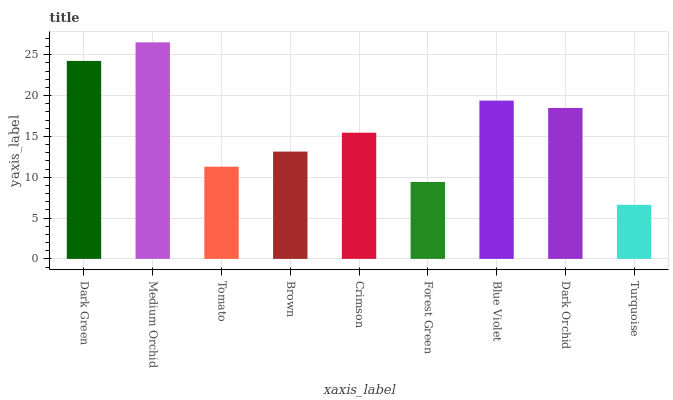Is Turquoise the minimum?
Answer yes or no. Yes. Is Medium Orchid the maximum?
Answer yes or no. Yes. Is Tomato the minimum?
Answer yes or no. No. Is Tomato the maximum?
Answer yes or no. No. Is Medium Orchid greater than Tomato?
Answer yes or no. Yes. Is Tomato less than Medium Orchid?
Answer yes or no. Yes. Is Tomato greater than Medium Orchid?
Answer yes or no. No. Is Medium Orchid less than Tomato?
Answer yes or no. No. Is Crimson the high median?
Answer yes or no. Yes. Is Crimson the low median?
Answer yes or no. Yes. Is Brown the high median?
Answer yes or no. No. Is Dark Orchid the low median?
Answer yes or no. No. 